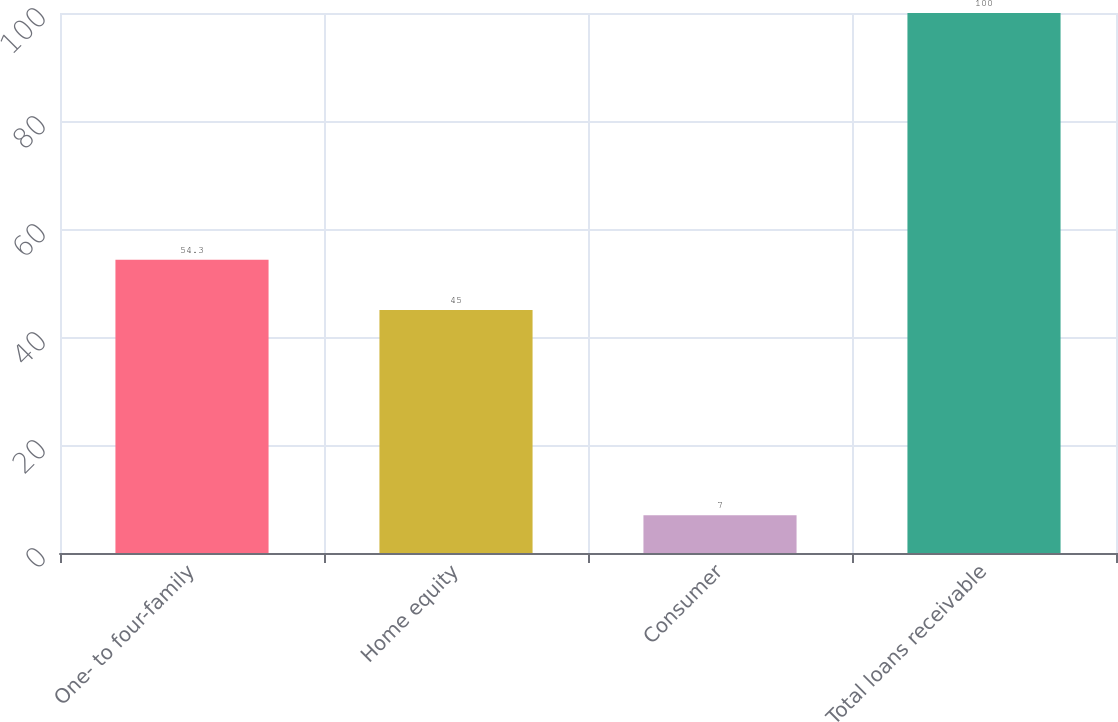Convert chart. <chart><loc_0><loc_0><loc_500><loc_500><bar_chart><fcel>One- to four-family<fcel>Home equity<fcel>Consumer<fcel>Total loans receivable<nl><fcel>54.3<fcel>45<fcel>7<fcel>100<nl></chart> 